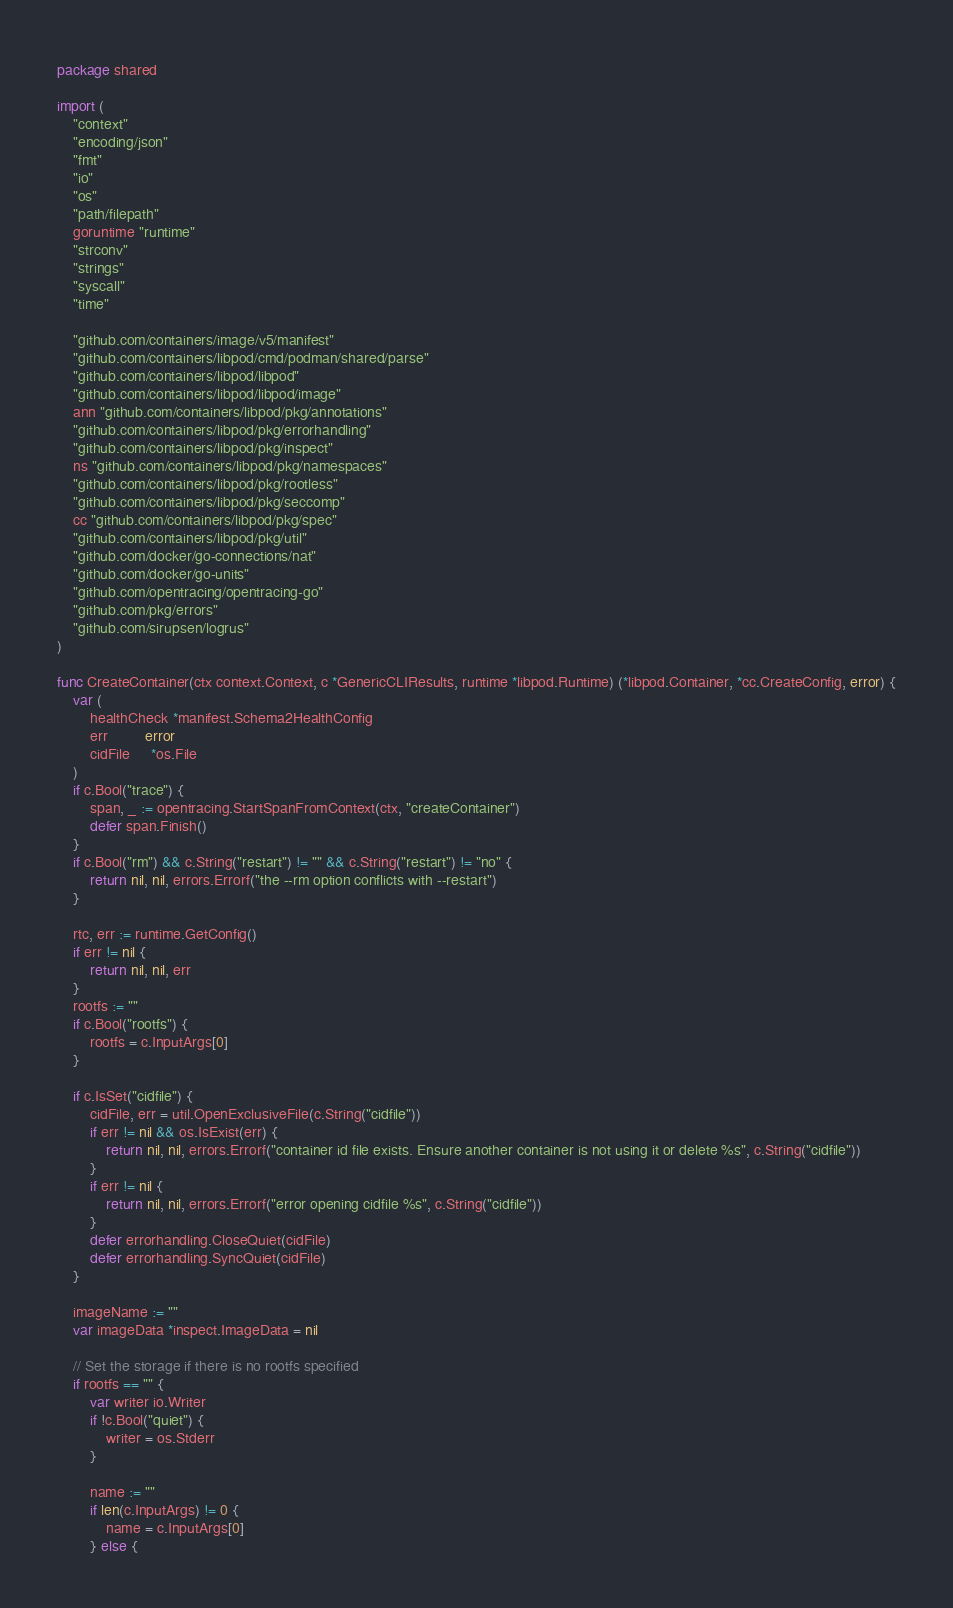Convert code to text. <code><loc_0><loc_0><loc_500><loc_500><_Go_>package shared

import (
	"context"
	"encoding/json"
	"fmt"
	"io"
	"os"
	"path/filepath"
	goruntime "runtime"
	"strconv"
	"strings"
	"syscall"
	"time"

	"github.com/containers/image/v5/manifest"
	"github.com/containers/libpod/cmd/podman/shared/parse"
	"github.com/containers/libpod/libpod"
	"github.com/containers/libpod/libpod/image"
	ann "github.com/containers/libpod/pkg/annotations"
	"github.com/containers/libpod/pkg/errorhandling"
	"github.com/containers/libpod/pkg/inspect"
	ns "github.com/containers/libpod/pkg/namespaces"
	"github.com/containers/libpod/pkg/rootless"
	"github.com/containers/libpod/pkg/seccomp"
	cc "github.com/containers/libpod/pkg/spec"
	"github.com/containers/libpod/pkg/util"
	"github.com/docker/go-connections/nat"
	"github.com/docker/go-units"
	"github.com/opentracing/opentracing-go"
	"github.com/pkg/errors"
	"github.com/sirupsen/logrus"
)

func CreateContainer(ctx context.Context, c *GenericCLIResults, runtime *libpod.Runtime) (*libpod.Container, *cc.CreateConfig, error) {
	var (
		healthCheck *manifest.Schema2HealthConfig
		err         error
		cidFile     *os.File
	)
	if c.Bool("trace") {
		span, _ := opentracing.StartSpanFromContext(ctx, "createContainer")
		defer span.Finish()
	}
	if c.Bool("rm") && c.String("restart") != "" && c.String("restart") != "no" {
		return nil, nil, errors.Errorf("the --rm option conflicts with --restart")
	}

	rtc, err := runtime.GetConfig()
	if err != nil {
		return nil, nil, err
	}
	rootfs := ""
	if c.Bool("rootfs") {
		rootfs = c.InputArgs[0]
	}

	if c.IsSet("cidfile") {
		cidFile, err = util.OpenExclusiveFile(c.String("cidfile"))
		if err != nil && os.IsExist(err) {
			return nil, nil, errors.Errorf("container id file exists. Ensure another container is not using it or delete %s", c.String("cidfile"))
		}
		if err != nil {
			return nil, nil, errors.Errorf("error opening cidfile %s", c.String("cidfile"))
		}
		defer errorhandling.CloseQuiet(cidFile)
		defer errorhandling.SyncQuiet(cidFile)
	}

	imageName := ""
	var imageData *inspect.ImageData = nil

	// Set the storage if there is no rootfs specified
	if rootfs == "" {
		var writer io.Writer
		if !c.Bool("quiet") {
			writer = os.Stderr
		}

		name := ""
		if len(c.InputArgs) != 0 {
			name = c.InputArgs[0]
		} else {</code> 